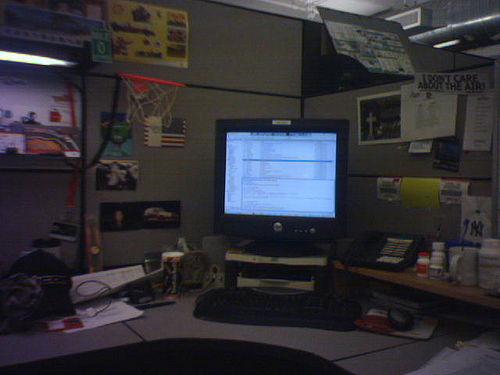Is the monitor inside a train?
Write a very short answer. No. What product is being advertised in the background?
Quick response, please. Basketball. Is this likely at a business?
Concise answer only. Yes. What is the center object used for?
Short answer required. Work. What kind of computer is this?
Give a very brief answer. Dell. What is on the floor with a handle?
Concise answer only. Chair. What sports equipment is here?
Concise answer only. Basketball hoop. What is on the TV screen?
Short answer required. Email. 